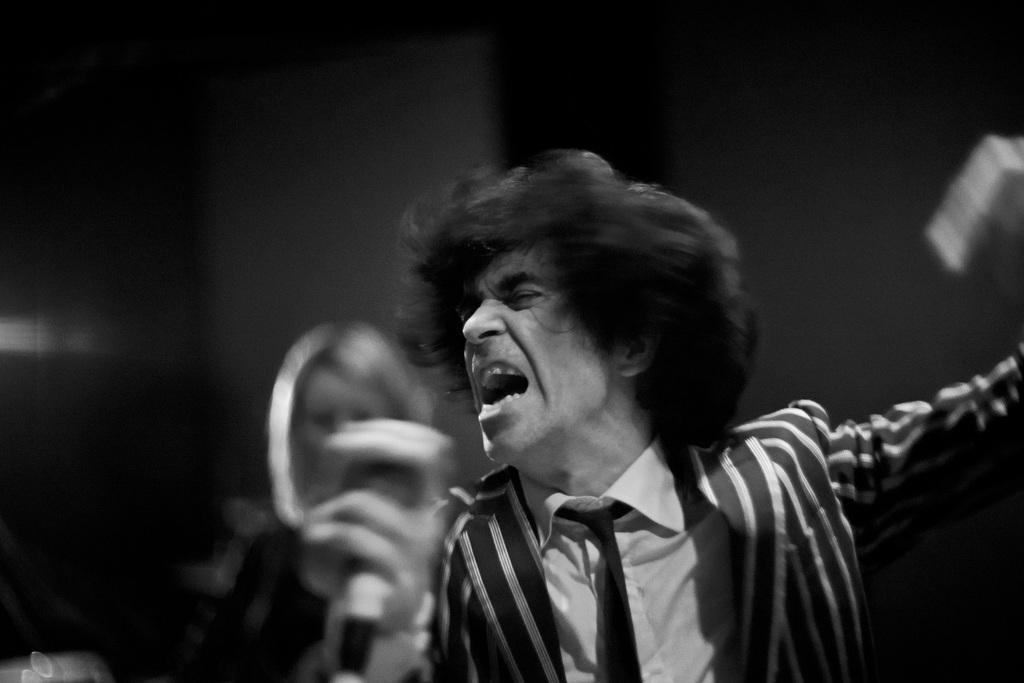Could you give a brief overview of what you see in this image? It is a black and white picture. In the center of the image we can see one person is standing and he is holding one microphone and he is in different costume. On the right side of the image we can see one white color object. In the background there is a wall, one person and a few other objects. 